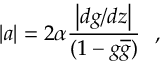<formula> <loc_0><loc_0><loc_500><loc_500>| a | = 2 \alpha \frac { \left | d g / d z \right | } { ( 1 - g \overline { g } ) } ,</formula> 